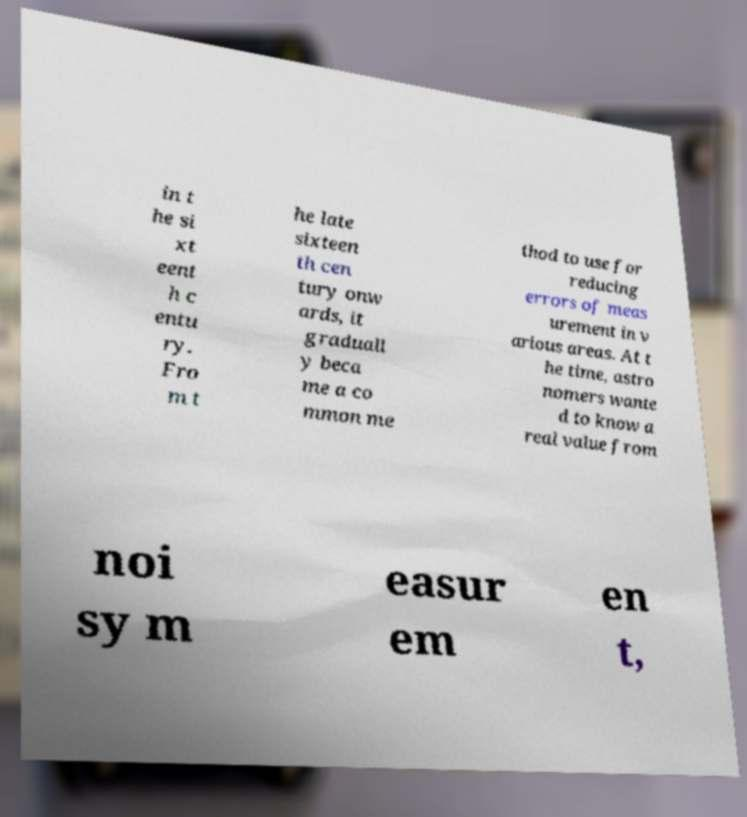There's text embedded in this image that I need extracted. Can you transcribe it verbatim? in t he si xt eent h c entu ry. Fro m t he late sixteen th cen tury onw ards, it graduall y beca me a co mmon me thod to use for reducing errors of meas urement in v arious areas. At t he time, astro nomers wante d to know a real value from noi sy m easur em en t, 